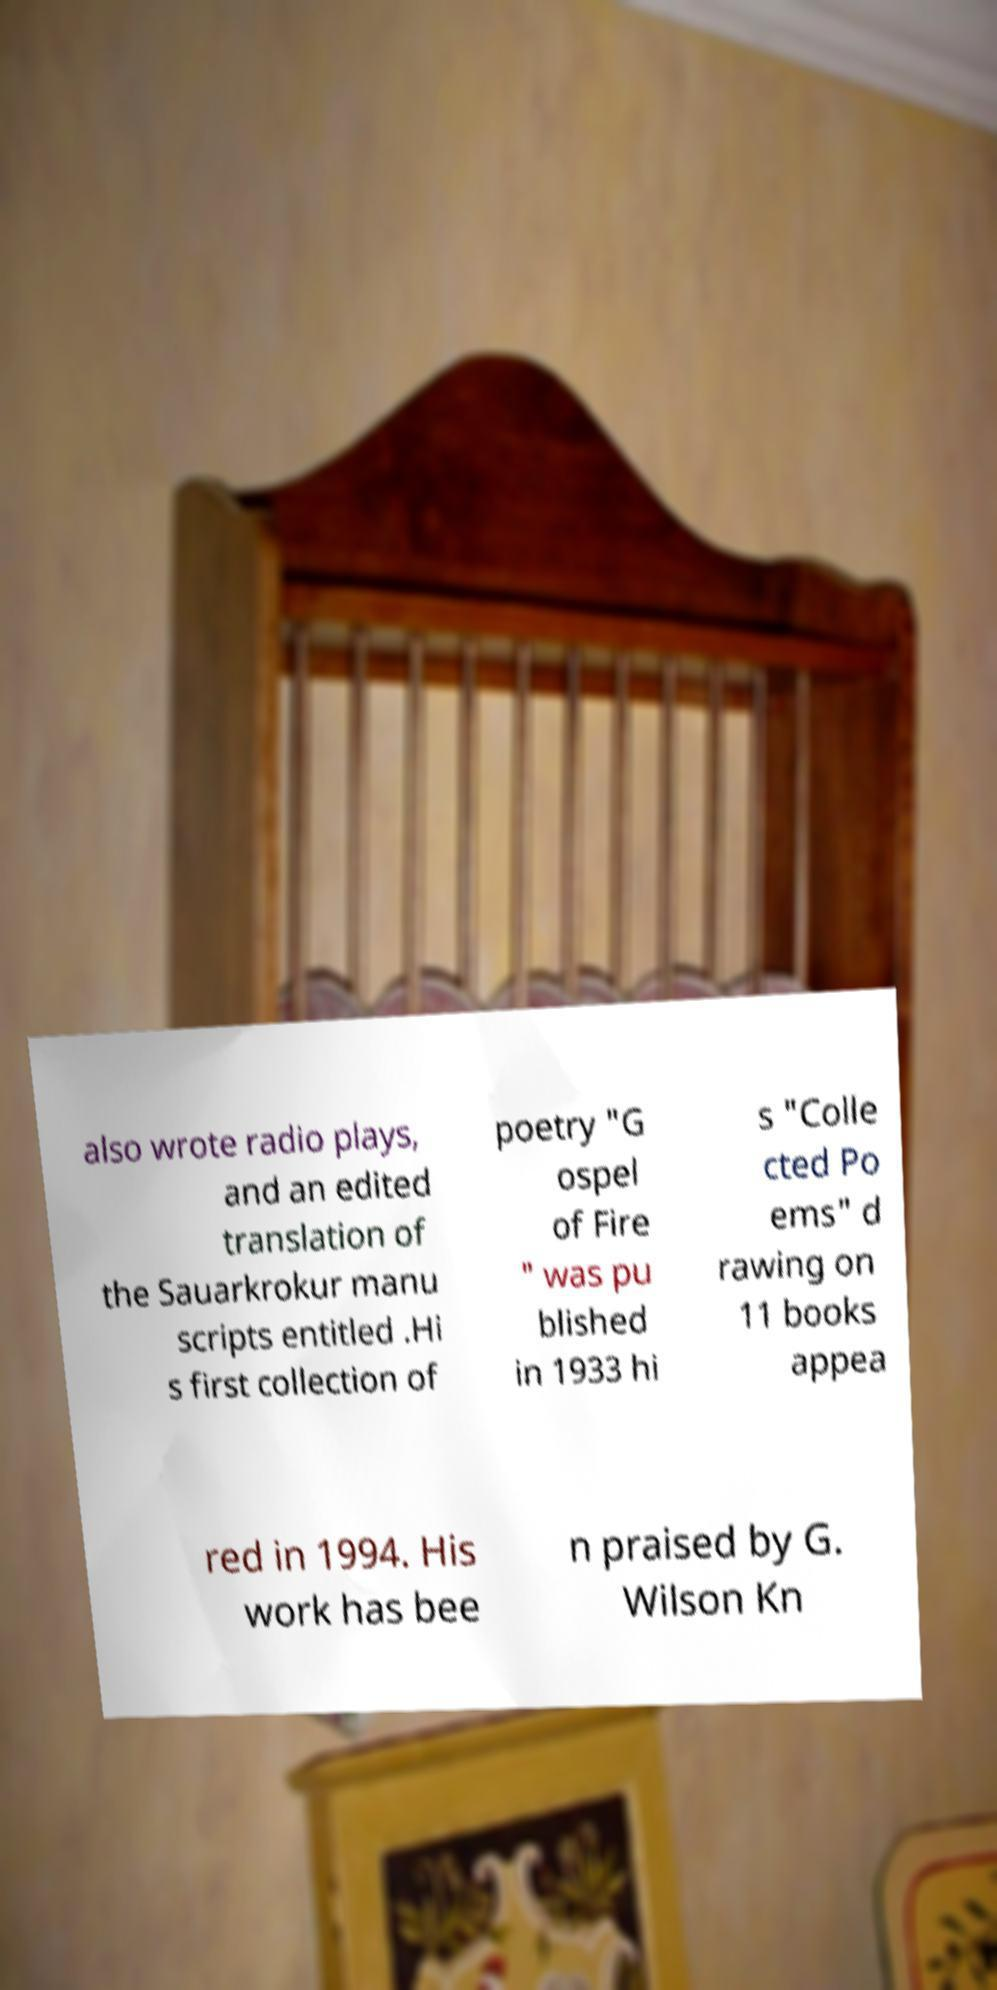Could you assist in decoding the text presented in this image and type it out clearly? also wrote radio plays, and an edited translation of the Sauarkrokur manu scripts entitled .Hi s first collection of poetry "G ospel of Fire " was pu blished in 1933 hi s "Colle cted Po ems" d rawing on 11 books appea red in 1994. His work has bee n praised by G. Wilson Kn 